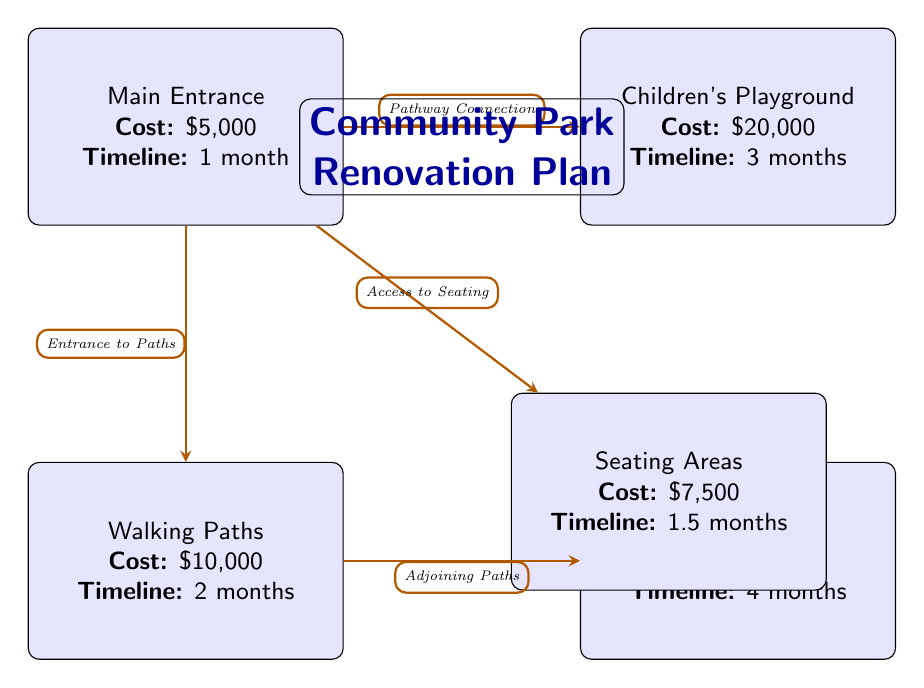What is the total cost of the Children's Playground? The cost of the Children's Playground is specifically listed in the diagram as $20,000.
Answer: $20,000 How many months is allocated for the construction of Seating Areas? The timeline for the Seating Areas is directly indicated in the diagram as 1.5 months.
Answer: 1.5 months What is the connection type between the Main Entrance and the Children's Playground? The diagram clearly states that there is a "Pathway Connection" linking the Main Entrance to the Children's Playground.
Answer: Pathway Connection Which area has the longest timeline? To determine this, we need to compare the timelines: the Children's Playground is 3 months, Walking Paths is 2 months, Green Spaces is 4 months, and Seating Areas is 1.5 months. Green Spaces has the longest timeline of 4 months.
Answer: Green Spaces How many total areas are represented in the diagram? Counting each labeled area (Main Entrance, Children's Playground, Walking Paths, Green Spaces, and Seating Areas), there are 5 areas represented in the diagram.
Answer: 5 What is the combined cost of the Walking Paths and the Seating Areas? The Walking Paths cost $10,000 and the Seating Areas cost $7,500. Adding these two costs gives $10,000 + $7,500 = $17,500.
Answer: $17,500 Which area provides access to Seating? The diagram indicates that the Main Entrance has an "Access to Seating" connection leading directly to the Seating Areas.
Answer: Main Entrance What is the relationship between Walking Paths and Green Spaces? The diagram shows that the Walking Paths have "Adjoining Paths" connecting them to the Green Spaces, indicating a direct relationship.
Answer: Adjoining Paths 